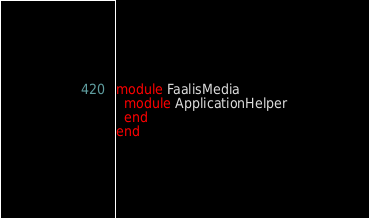<code> <loc_0><loc_0><loc_500><loc_500><_Ruby_>module FaalisMedia
  module ApplicationHelper
  end
end
</code> 